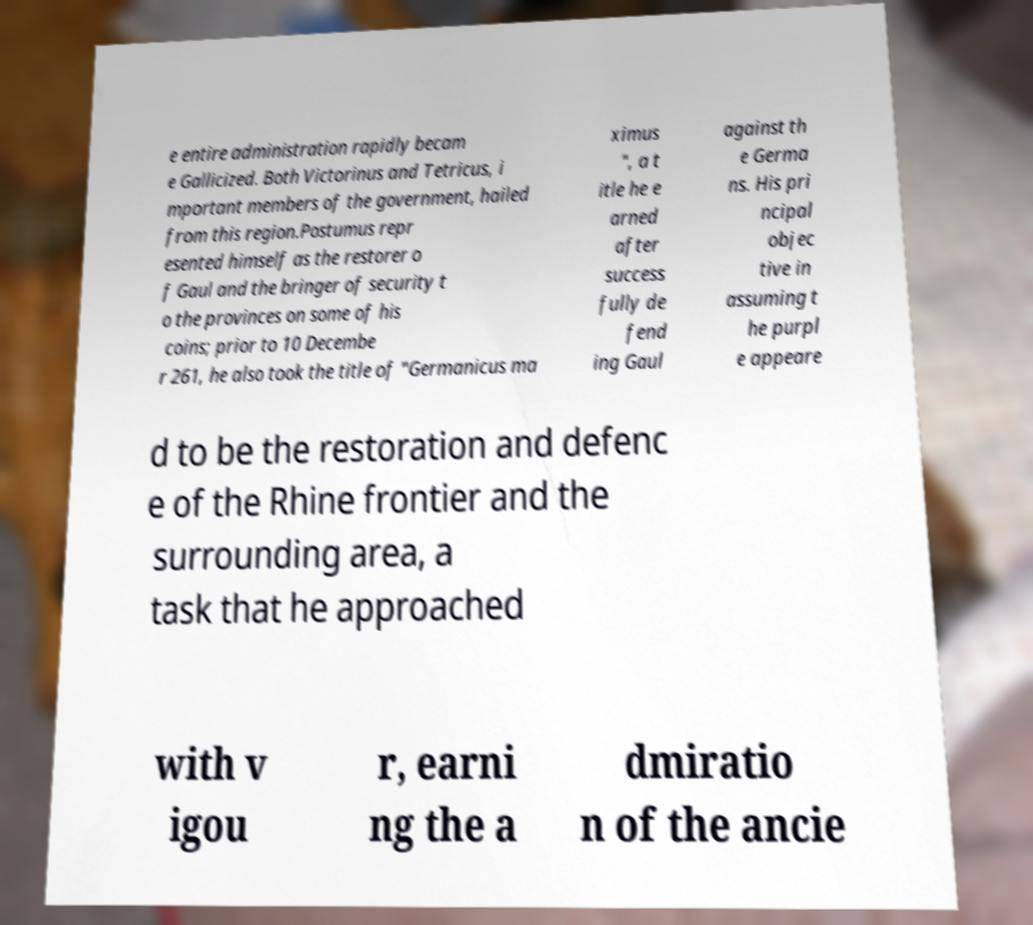What messages or text are displayed in this image? I need them in a readable, typed format. e entire administration rapidly becam e Gallicized. Both Victorinus and Tetricus, i mportant members of the government, hailed from this region.Postumus repr esented himself as the restorer o f Gaul and the bringer of security t o the provinces on some of his coins; prior to 10 Decembe r 261, he also took the title of "Germanicus ma ximus ", a t itle he e arned after success fully de fend ing Gaul against th e Germa ns. His pri ncipal objec tive in assuming t he purpl e appeare d to be the restoration and defenc e of the Rhine frontier and the surrounding area, a task that he approached with v igou r, earni ng the a dmiratio n of the ancie 